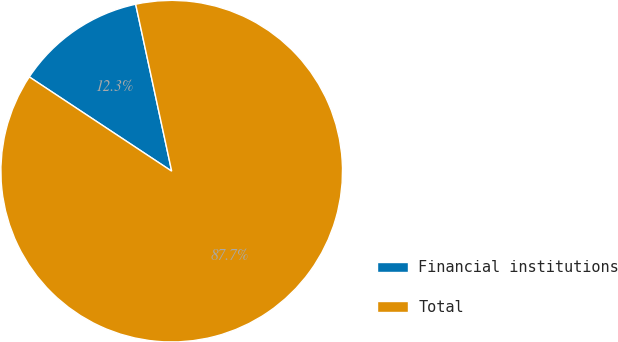<chart> <loc_0><loc_0><loc_500><loc_500><pie_chart><fcel>Financial institutions<fcel>Total<nl><fcel>12.31%<fcel>87.69%<nl></chart> 